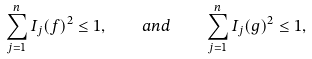Convert formula to latex. <formula><loc_0><loc_0><loc_500><loc_500>\sum _ { j = 1 } ^ { n } I _ { j } ( f ) ^ { 2 } \leq 1 , \quad a n d \quad \sum _ { j = 1 } ^ { n } I _ { j } ( g ) ^ { 2 } \leq 1 ,</formula> 